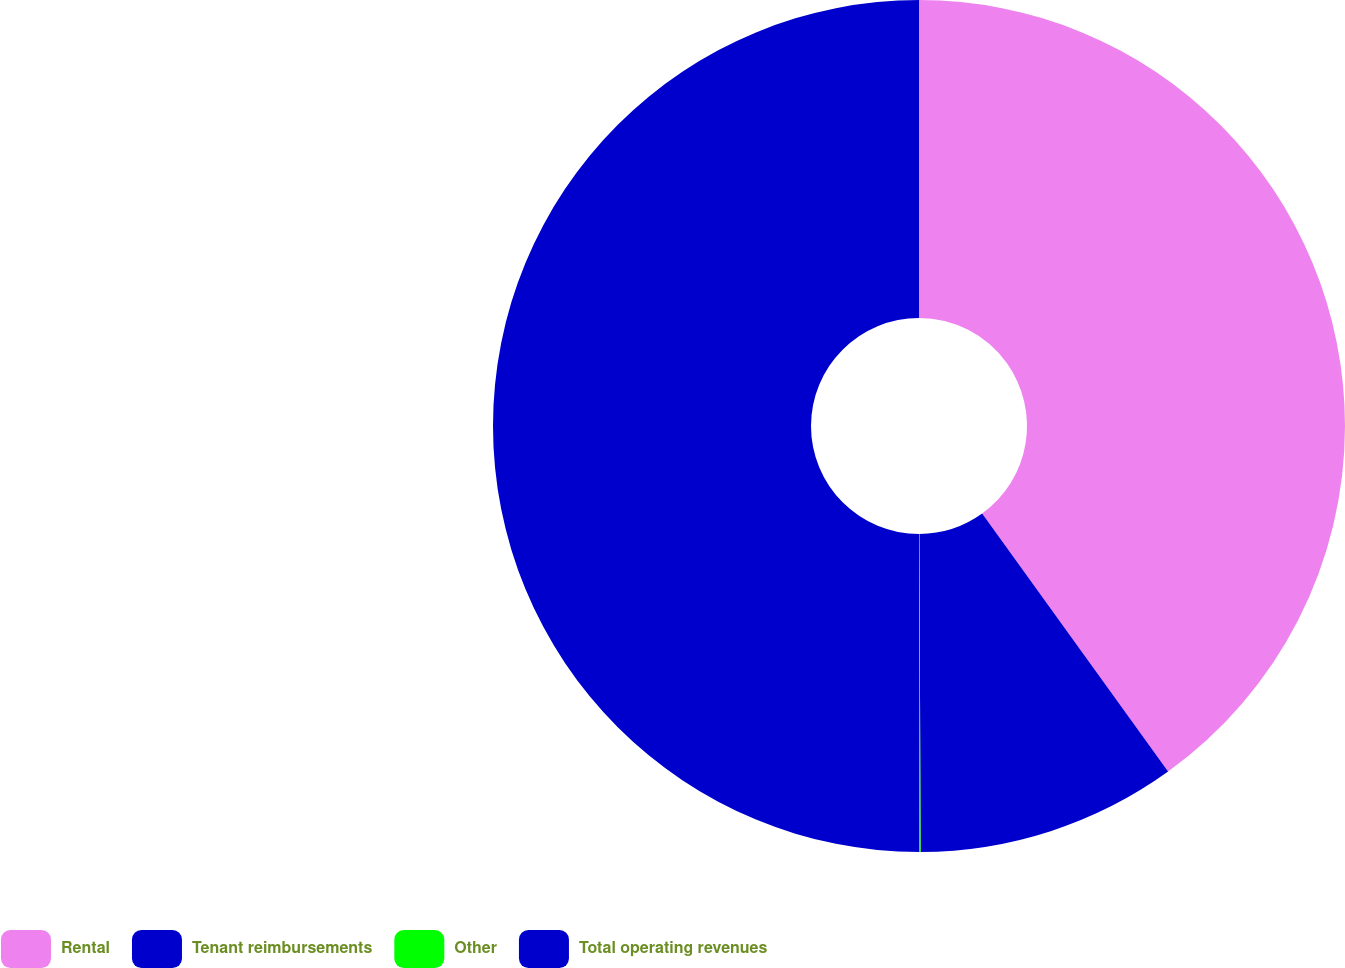Convert chart to OTSL. <chart><loc_0><loc_0><loc_500><loc_500><pie_chart><fcel>Rental<fcel>Tenant reimbursements<fcel>Other<fcel>Total operating revenues<nl><fcel>40.06%<fcel>9.88%<fcel>0.06%<fcel>50.0%<nl></chart> 